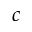Convert formula to latex. <formula><loc_0><loc_0><loc_500><loc_500>c</formula> 